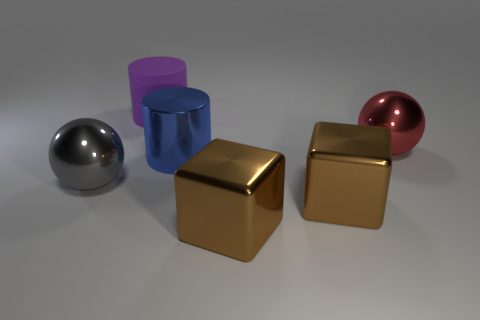What number of brown objects are either large cylinders or big metal objects?
Keep it short and to the point. 2. Are there fewer metallic blocks that are right of the large red metallic object than big brown matte balls?
Your answer should be very brief. No. How many big cylinders are on the left side of the metallic sphere that is to the left of the purple cylinder?
Keep it short and to the point. 0. How many other things are there of the same size as the blue cylinder?
Provide a short and direct response. 5. How many things are gray balls or big objects that are behind the large gray thing?
Offer a terse response. 4. Is the number of things less than the number of big yellow spheres?
Your answer should be compact. No. There is a object that is behind the large ball to the right of the large gray metallic ball; what color is it?
Ensure brevity in your answer.  Purple. What is the material of the purple thing that is the same shape as the blue metallic thing?
Your answer should be very brief. Rubber. What number of shiny objects are balls or big red spheres?
Offer a very short reply. 2. Is the material of the big cylinder in front of the big purple object the same as the big cylinder to the left of the blue metal object?
Keep it short and to the point. No. 